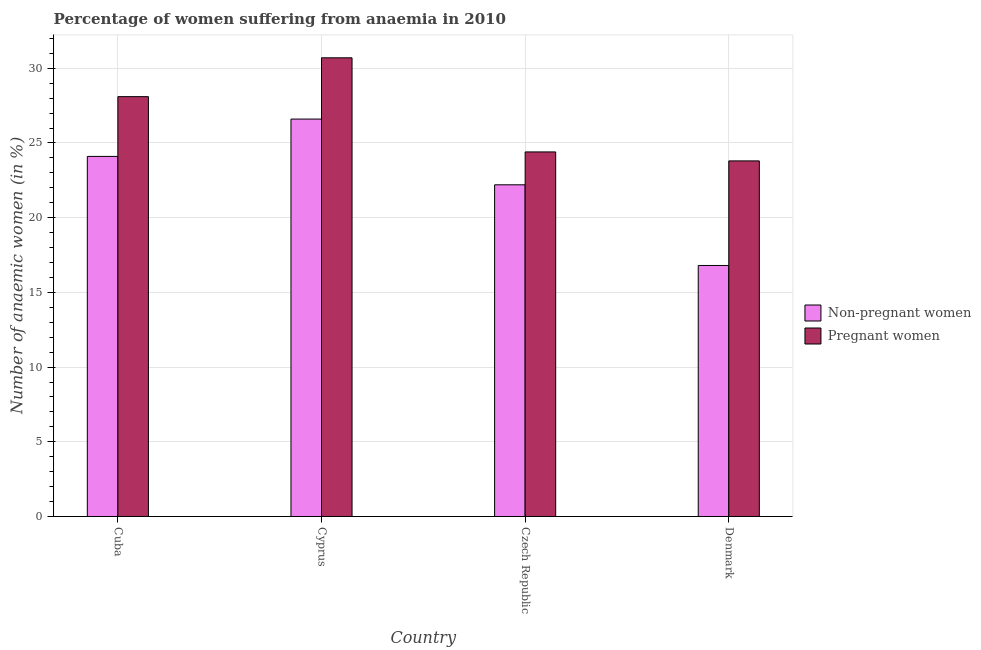Are the number of bars per tick equal to the number of legend labels?
Make the answer very short. Yes. Are the number of bars on each tick of the X-axis equal?
Your response must be concise. Yes. How many bars are there on the 2nd tick from the left?
Offer a very short reply. 2. How many bars are there on the 1st tick from the right?
Provide a succinct answer. 2. What is the label of the 1st group of bars from the left?
Your response must be concise. Cuba. What is the percentage of pregnant anaemic women in Czech Republic?
Offer a very short reply. 24.4. Across all countries, what is the maximum percentage of pregnant anaemic women?
Provide a short and direct response. 30.7. Across all countries, what is the minimum percentage of pregnant anaemic women?
Keep it short and to the point. 23.8. In which country was the percentage of non-pregnant anaemic women maximum?
Ensure brevity in your answer.  Cyprus. In which country was the percentage of pregnant anaemic women minimum?
Provide a succinct answer. Denmark. What is the total percentage of pregnant anaemic women in the graph?
Provide a short and direct response. 107. What is the difference between the percentage of non-pregnant anaemic women in Cuba and that in Denmark?
Your answer should be compact. 7.3. What is the difference between the percentage of pregnant anaemic women in Cuba and the percentage of non-pregnant anaemic women in Czech Republic?
Your answer should be very brief. 5.9. What is the average percentage of pregnant anaemic women per country?
Give a very brief answer. 26.75. What is the difference between the percentage of pregnant anaemic women and percentage of non-pregnant anaemic women in Denmark?
Give a very brief answer. 7. What is the ratio of the percentage of pregnant anaemic women in Czech Republic to that in Denmark?
Give a very brief answer. 1.03. What is the difference between the highest and the second highest percentage of non-pregnant anaemic women?
Your answer should be very brief. 2.5. What is the difference between the highest and the lowest percentage of pregnant anaemic women?
Make the answer very short. 6.9. Is the sum of the percentage of non-pregnant anaemic women in Cuba and Czech Republic greater than the maximum percentage of pregnant anaemic women across all countries?
Offer a terse response. Yes. What does the 2nd bar from the left in Cuba represents?
Make the answer very short. Pregnant women. What does the 1st bar from the right in Cyprus represents?
Offer a terse response. Pregnant women. How many bars are there?
Your response must be concise. 8. Are all the bars in the graph horizontal?
Ensure brevity in your answer.  No. How many countries are there in the graph?
Offer a very short reply. 4. What is the difference between two consecutive major ticks on the Y-axis?
Your answer should be very brief. 5. Are the values on the major ticks of Y-axis written in scientific E-notation?
Your answer should be very brief. No. Does the graph contain any zero values?
Provide a short and direct response. No. Does the graph contain grids?
Your response must be concise. Yes. How many legend labels are there?
Your answer should be compact. 2. What is the title of the graph?
Provide a short and direct response. Percentage of women suffering from anaemia in 2010. Does "Broad money growth" appear as one of the legend labels in the graph?
Give a very brief answer. No. What is the label or title of the Y-axis?
Provide a short and direct response. Number of anaemic women (in %). What is the Number of anaemic women (in %) of Non-pregnant women in Cuba?
Your answer should be compact. 24.1. What is the Number of anaemic women (in %) in Pregnant women in Cuba?
Offer a terse response. 28.1. What is the Number of anaemic women (in %) of Non-pregnant women in Cyprus?
Offer a terse response. 26.6. What is the Number of anaemic women (in %) in Pregnant women in Cyprus?
Keep it short and to the point. 30.7. What is the Number of anaemic women (in %) of Non-pregnant women in Czech Republic?
Your answer should be compact. 22.2. What is the Number of anaemic women (in %) of Pregnant women in Czech Republic?
Provide a succinct answer. 24.4. What is the Number of anaemic women (in %) of Pregnant women in Denmark?
Your answer should be very brief. 23.8. Across all countries, what is the maximum Number of anaemic women (in %) of Non-pregnant women?
Your answer should be compact. 26.6. Across all countries, what is the maximum Number of anaemic women (in %) in Pregnant women?
Ensure brevity in your answer.  30.7. Across all countries, what is the minimum Number of anaemic women (in %) of Non-pregnant women?
Provide a short and direct response. 16.8. Across all countries, what is the minimum Number of anaemic women (in %) in Pregnant women?
Keep it short and to the point. 23.8. What is the total Number of anaemic women (in %) in Non-pregnant women in the graph?
Give a very brief answer. 89.7. What is the total Number of anaemic women (in %) of Pregnant women in the graph?
Give a very brief answer. 107. What is the difference between the Number of anaemic women (in %) of Non-pregnant women in Cuba and that in Cyprus?
Your response must be concise. -2.5. What is the difference between the Number of anaemic women (in %) in Pregnant women in Cuba and that in Cyprus?
Provide a succinct answer. -2.6. What is the difference between the Number of anaemic women (in %) in Pregnant women in Cuba and that in Denmark?
Offer a terse response. 4.3. What is the difference between the Number of anaemic women (in %) of Non-pregnant women in Cuba and the Number of anaemic women (in %) of Pregnant women in Cyprus?
Provide a short and direct response. -6.6. What is the difference between the Number of anaemic women (in %) of Non-pregnant women in Cyprus and the Number of anaemic women (in %) of Pregnant women in Czech Republic?
Keep it short and to the point. 2.2. What is the average Number of anaemic women (in %) in Non-pregnant women per country?
Keep it short and to the point. 22.43. What is the average Number of anaemic women (in %) of Pregnant women per country?
Keep it short and to the point. 26.75. What is the difference between the Number of anaemic women (in %) of Non-pregnant women and Number of anaemic women (in %) of Pregnant women in Cyprus?
Make the answer very short. -4.1. What is the ratio of the Number of anaemic women (in %) in Non-pregnant women in Cuba to that in Cyprus?
Keep it short and to the point. 0.91. What is the ratio of the Number of anaemic women (in %) in Pregnant women in Cuba to that in Cyprus?
Ensure brevity in your answer.  0.92. What is the ratio of the Number of anaemic women (in %) of Non-pregnant women in Cuba to that in Czech Republic?
Offer a terse response. 1.09. What is the ratio of the Number of anaemic women (in %) of Pregnant women in Cuba to that in Czech Republic?
Keep it short and to the point. 1.15. What is the ratio of the Number of anaemic women (in %) in Non-pregnant women in Cuba to that in Denmark?
Make the answer very short. 1.43. What is the ratio of the Number of anaemic women (in %) in Pregnant women in Cuba to that in Denmark?
Make the answer very short. 1.18. What is the ratio of the Number of anaemic women (in %) in Non-pregnant women in Cyprus to that in Czech Republic?
Provide a short and direct response. 1.2. What is the ratio of the Number of anaemic women (in %) in Pregnant women in Cyprus to that in Czech Republic?
Your response must be concise. 1.26. What is the ratio of the Number of anaemic women (in %) of Non-pregnant women in Cyprus to that in Denmark?
Ensure brevity in your answer.  1.58. What is the ratio of the Number of anaemic women (in %) in Pregnant women in Cyprus to that in Denmark?
Your answer should be very brief. 1.29. What is the ratio of the Number of anaemic women (in %) in Non-pregnant women in Czech Republic to that in Denmark?
Give a very brief answer. 1.32. What is the ratio of the Number of anaemic women (in %) of Pregnant women in Czech Republic to that in Denmark?
Offer a very short reply. 1.03. What is the difference between the highest and the lowest Number of anaemic women (in %) of Non-pregnant women?
Provide a succinct answer. 9.8. 